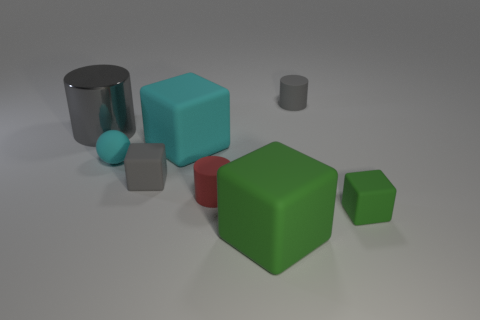There is a object that is both behind the cyan rubber ball and in front of the gray metal object; how big is it?
Offer a terse response. Large. How many cubes are either small rubber things or big green things?
Ensure brevity in your answer.  3. There is another rubber cube that is the same size as the cyan block; what is its color?
Provide a succinct answer. Green. Is there any other thing that has the same shape as the tiny cyan object?
Your answer should be very brief. No. The other big thing that is the same shape as the red rubber thing is what color?
Ensure brevity in your answer.  Gray. How many things are large gray things or gray objects that are to the right of the metal cylinder?
Keep it short and to the point. 3. Are there fewer small gray rubber things that are in front of the tiny cyan matte thing than cyan rubber things?
Keep it short and to the point. Yes. How big is the cylinder in front of the tiny gray rubber thing that is to the left of the tiny rubber cylinder in front of the sphere?
Provide a short and direct response. Small. What is the color of the rubber thing that is both to the left of the large cyan object and in front of the cyan sphere?
Keep it short and to the point. Gray. How many red matte cylinders are there?
Keep it short and to the point. 1. 